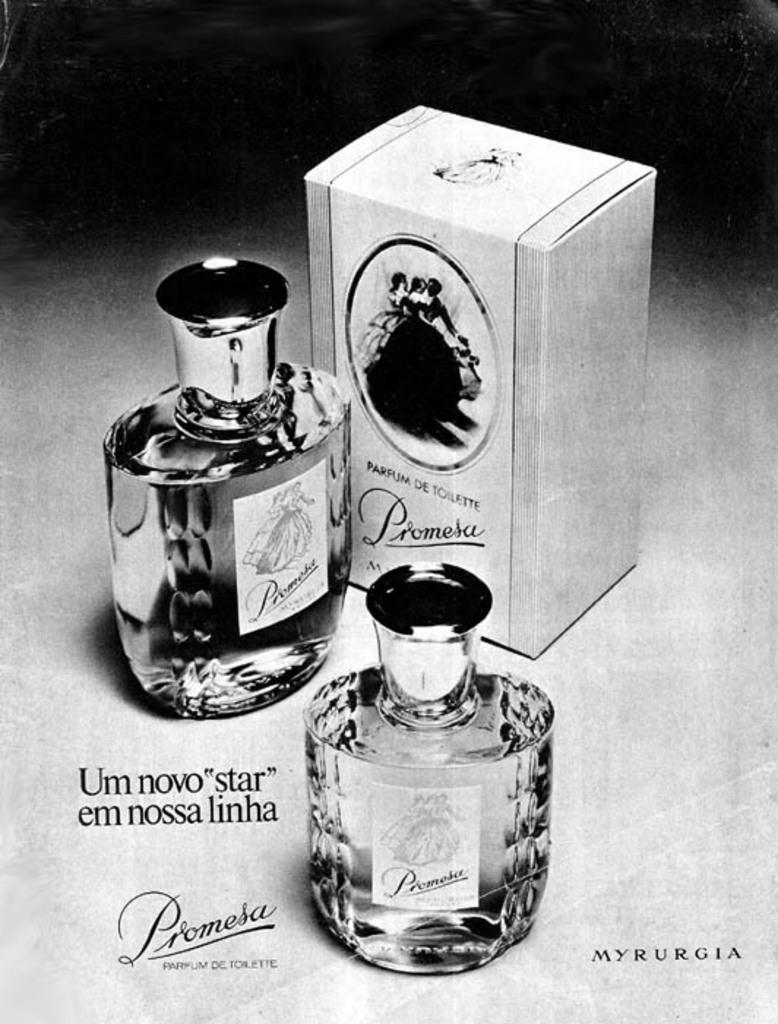<image>
Share a concise interpretation of the image provided. A perfume ad displaying the perfume Prometa with the perfume box and bottle beside 